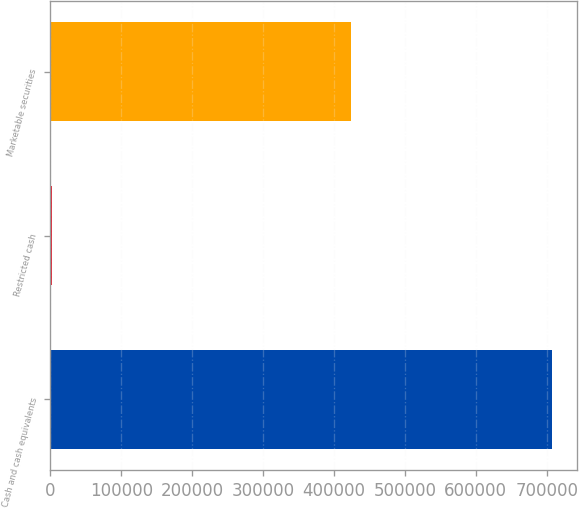Convert chart to OTSL. <chart><loc_0><loc_0><loc_500><loc_500><bar_chart><fcel>Cash and cash equivalents<fcel>Restricted cash<fcel>Marketable securities<nl><fcel>707689<fcel>1554<fcel>424505<nl></chart> 